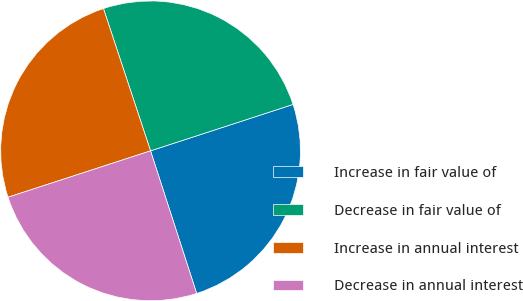Convert chart. <chart><loc_0><loc_0><loc_500><loc_500><pie_chart><fcel>Increase in fair value of<fcel>Decrease in fair value of<fcel>Increase in annual interest<fcel>Decrease in annual interest<nl><fcel>25.03%<fcel>25.08%<fcel>24.92%<fcel>24.97%<nl></chart> 